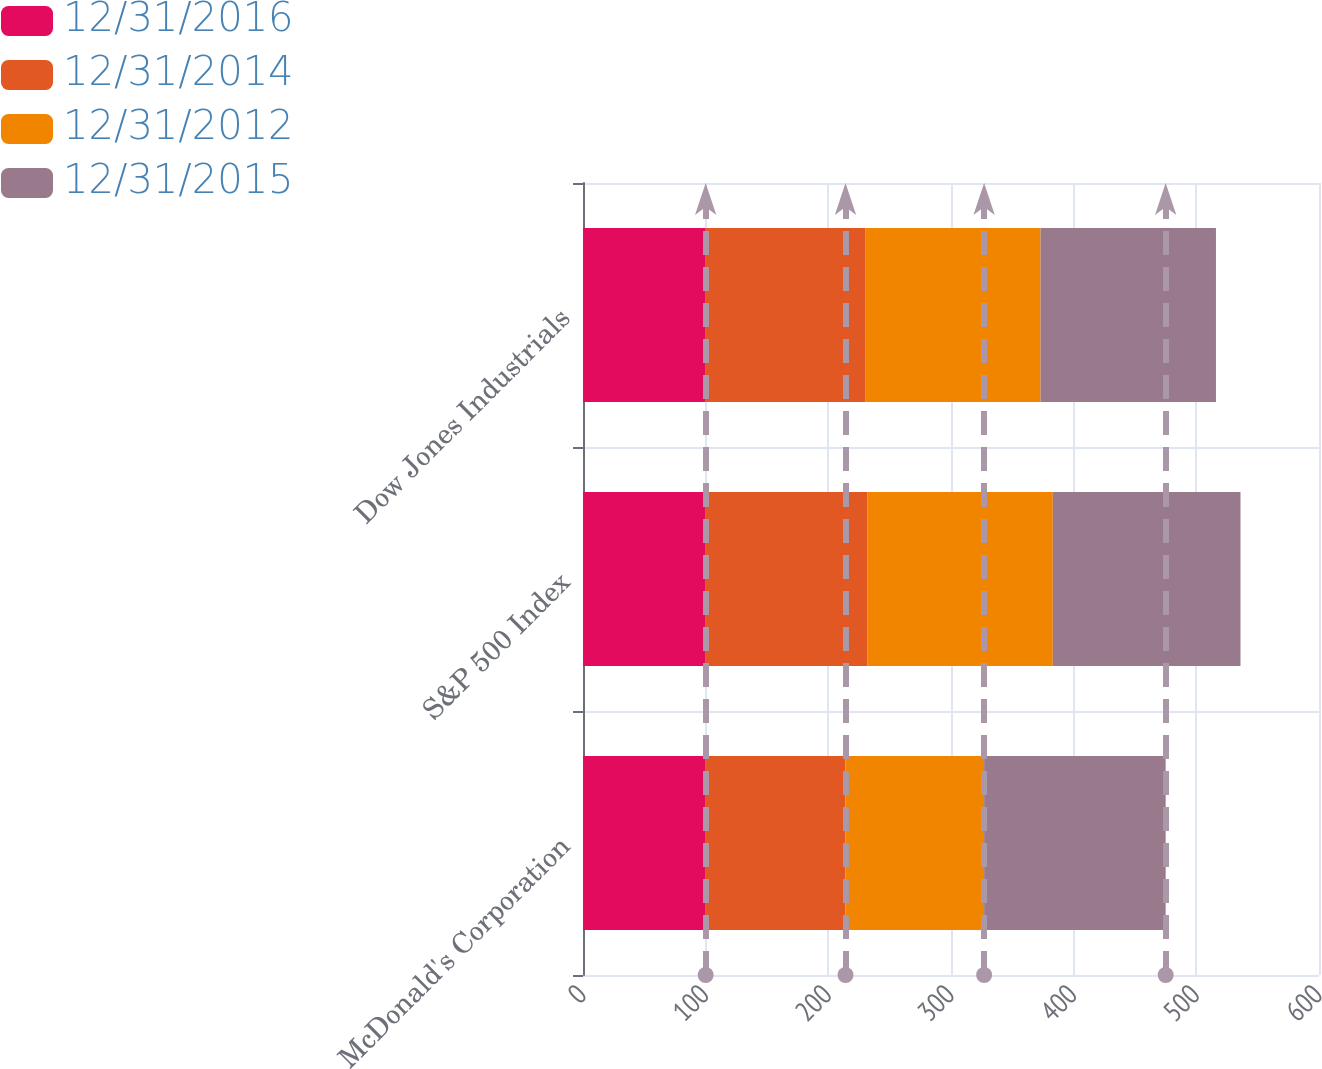<chart> <loc_0><loc_0><loc_500><loc_500><stacked_bar_chart><ecel><fcel>McDonald's Corporation<fcel>S&P 500 Index<fcel>Dow Jones Industrials<nl><fcel>12/31/2016<fcel>100<fcel>100<fcel>100<nl><fcel>12/31/2014<fcel>114<fcel>132<fcel>130<nl><fcel>12/31/2012<fcel>113<fcel>151<fcel>143<nl><fcel>12/31/2015<fcel>148<fcel>153<fcel>143<nl></chart> 